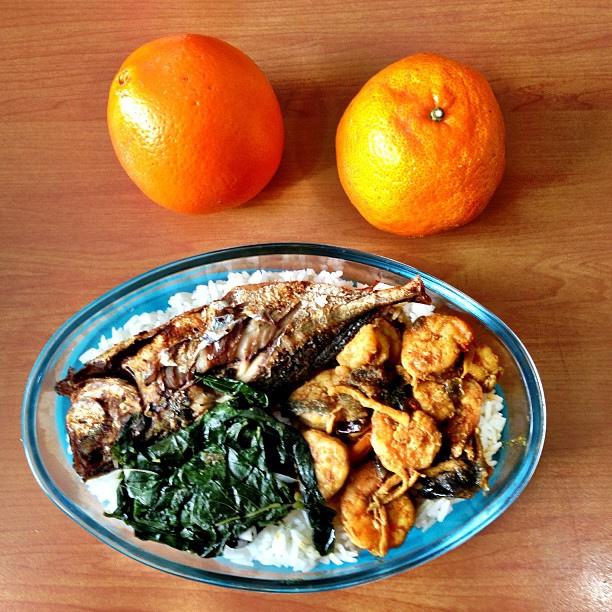What is the green vegetable?
Concise answer only. Spinach. What is the table made of?
Write a very short answer. Wood. How many oranges here?
Write a very short answer. 2. Are the two fruits touching?
Concise answer only. No. What is the green food?
Short answer required. Spinach. 